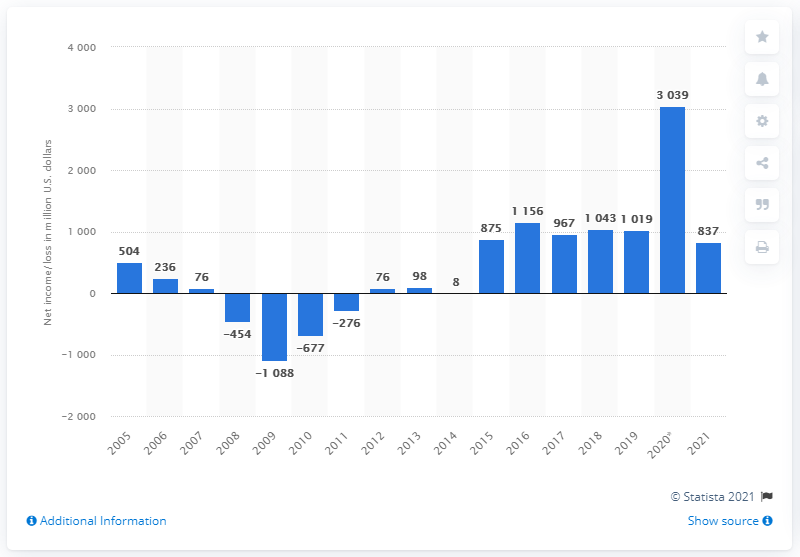Point out several critical features in this image. Electronic Arts generated a net income of $3039 million in 2020. Electronic Arts generated approximately $837 million in revenue during the 2021 fiscal year. 